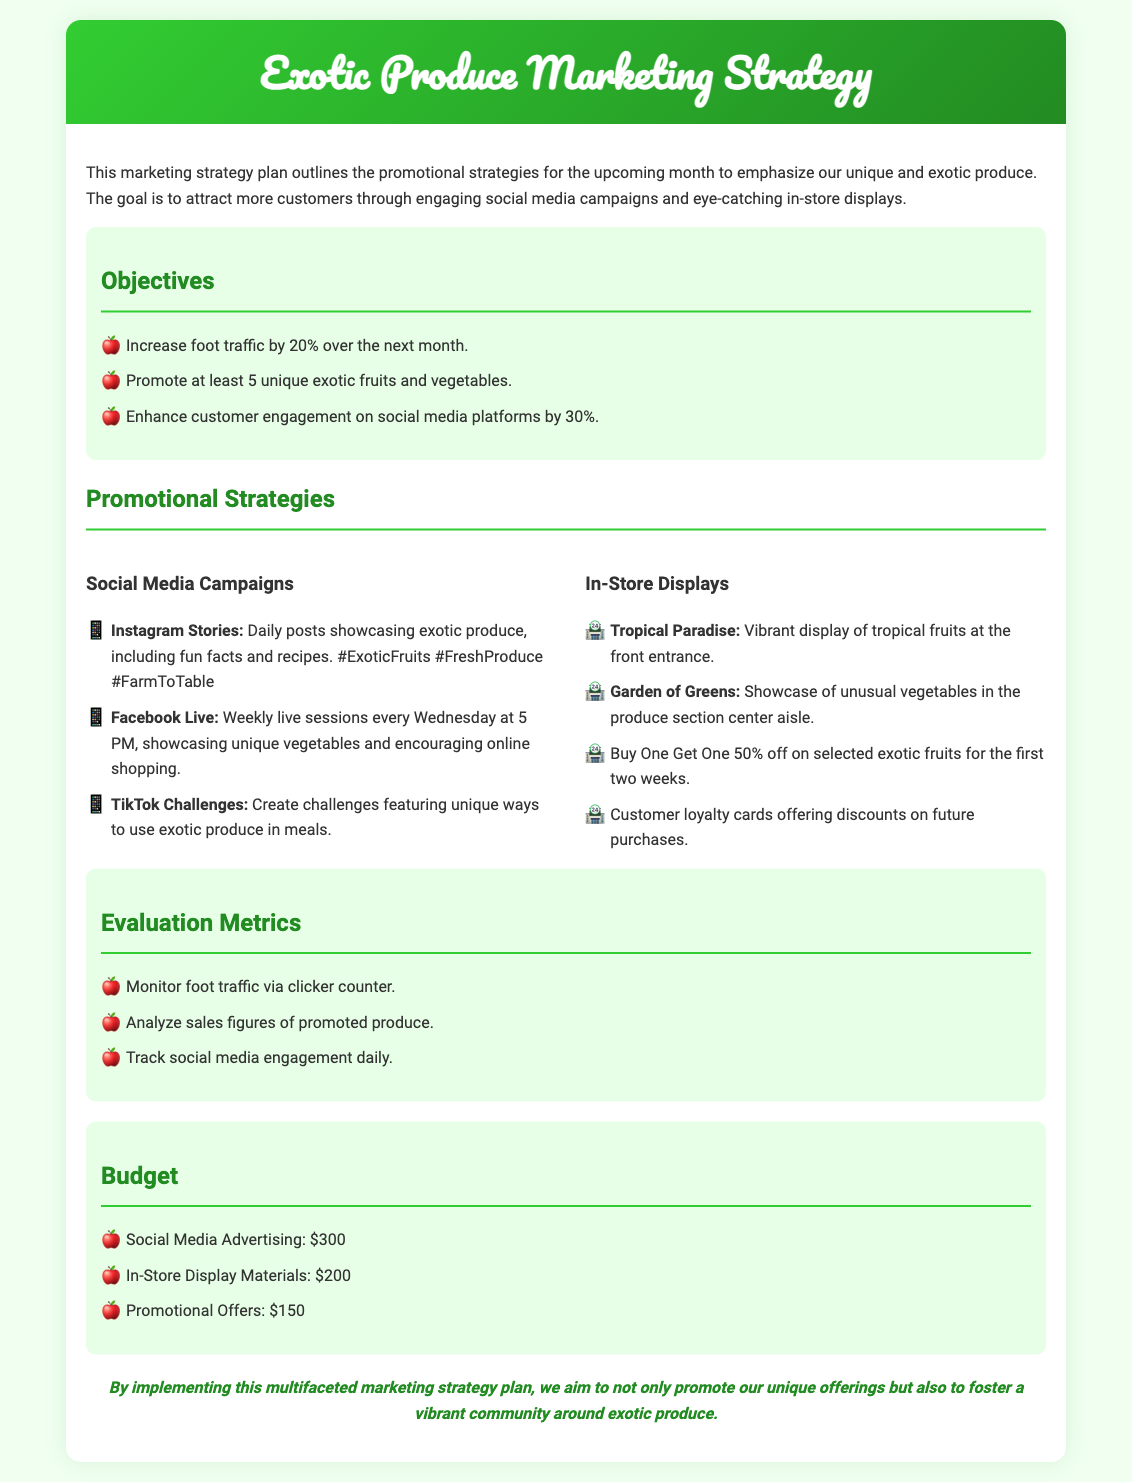What is the goal of the marketing strategy plan? The goal is to attract more customers through engaging social media campaigns and eye-catching in-store displays.
Answer: Attract more customers How much is allocated for social media advertising? The budget includes specific amounts for various promotional activities, one of which is for social media advertising.
Answer: $300 What promotional strategy is planned for Facebook? A specific promotional strategy is outlined for Facebook, which involves live sessions.
Answer: Live Sessions How many unique exotic fruits and vegetables are to be promoted? The plan includes a goal for the number of unique offerings to promote.
Answer: 5 What is the percentage increase in customer engagement targeted for social media? The objectives section specifies the targeted percentage increase for customer engagement on social media.
Answer: 30% What display is mentioned for the front entrance? The in-store display section specifies a vibrant display located at the front entrance.
Answer: Tropical Paradise On which day and time will the Facebook live sessions be held? The document states the specific time and day for the live sessions on Facebook.
Answer: Wednesdays at 5 PM What discount is offered on selected exotic fruits for the first two weeks? The promotional offers detail a specific discount during the initial period.
Answer: Buy One Get One 50% off What tool will be used to monitor foot traffic? The evaluation metrics specify a method for tracking foot traffic.
Answer: Clicker counter 